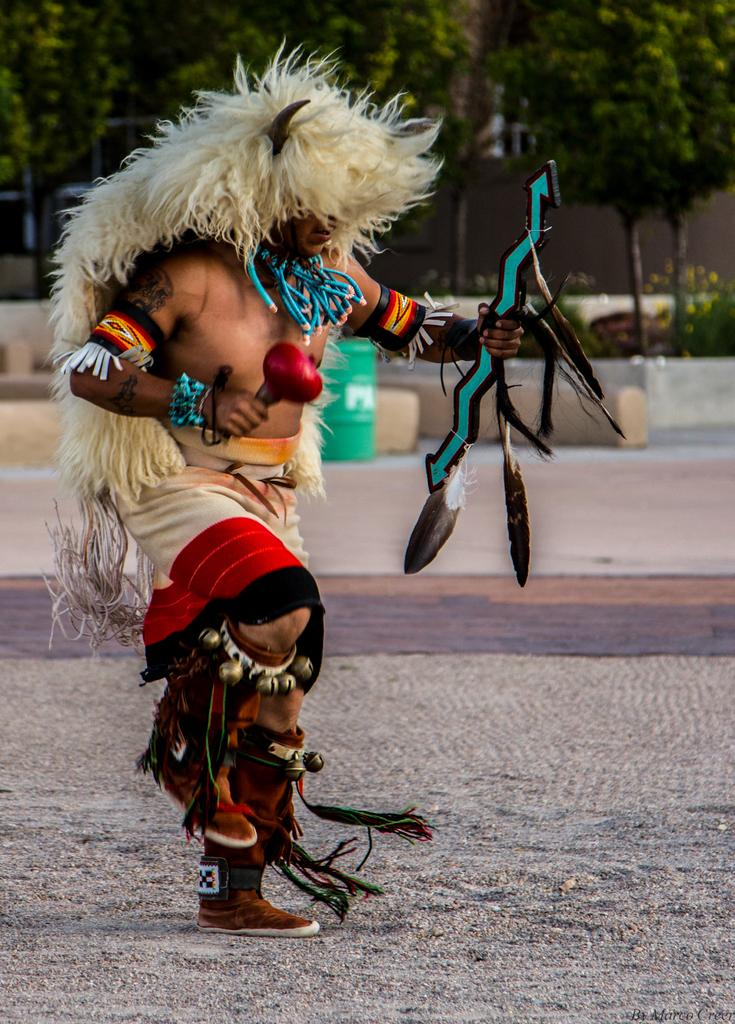What is the main subject of the image? There is a man standing in the middle of the image. What is the man holding in the image? The man is holding something. What can be seen in the background of the image? There are trees and plants behind the man, as well as walls and buildings. Can you tell me how many times the man pumps his fist in the image? There is no indication in the image that the man is pumping his fist, so it cannot be determined from the picture. 